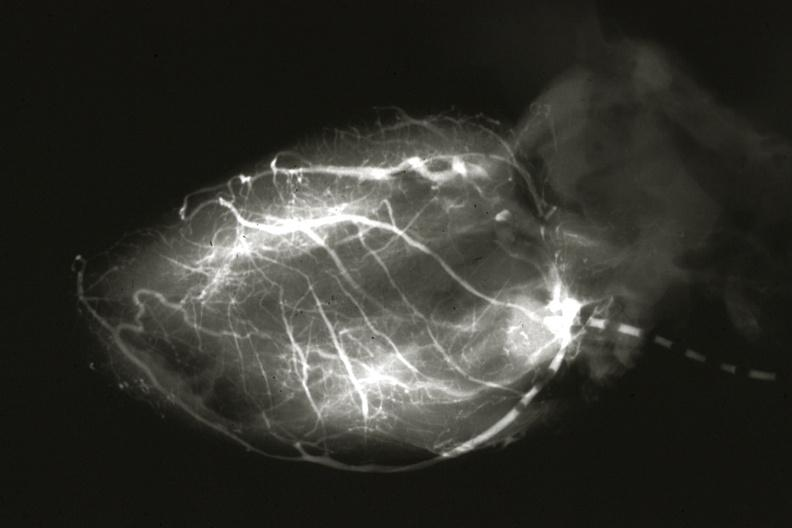what is present?
Answer the question using a single word or phrase. Coronary artery anomalous origin left from pulmonary artery 